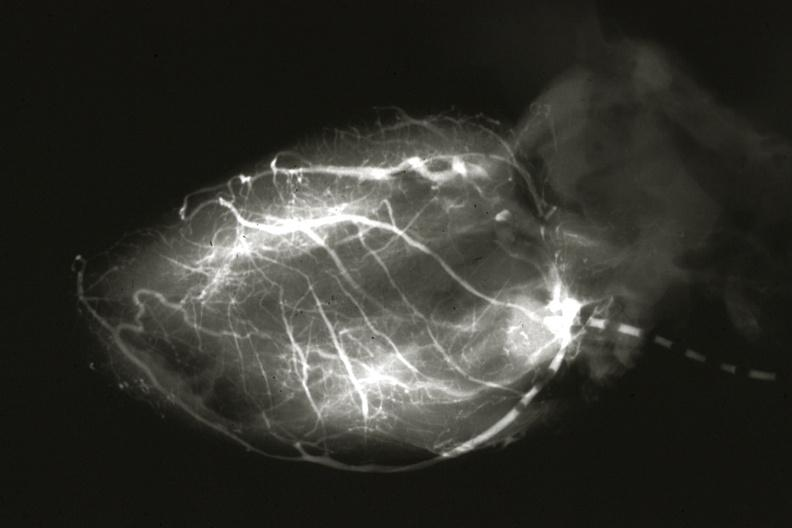what is present?
Answer the question using a single word or phrase. Coronary artery anomalous origin left from pulmonary artery 